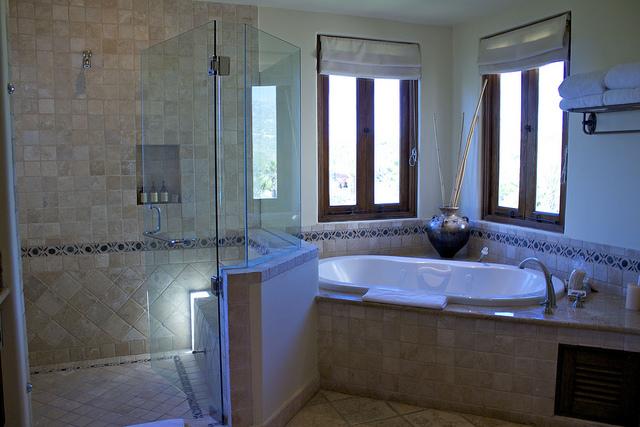Is the shower door open or closed?
Answer briefly. Open. Are there flowers in that pot?
Concise answer only. No. What is the area called on the wall back of the tub?
Write a very short answer. Backsplash. How many windows are above the tub?
Concise answer only. 2. 